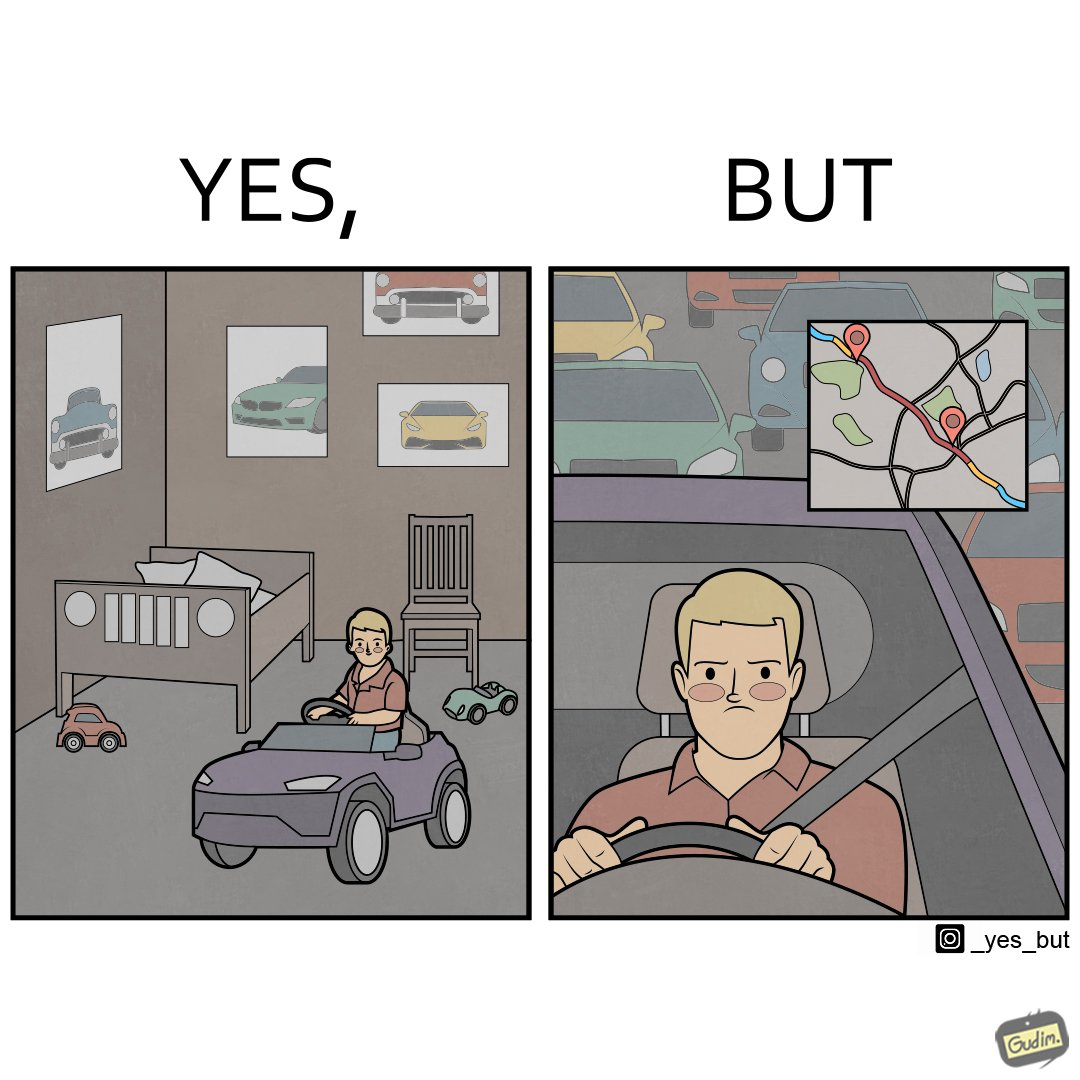What does this image depict? The image is funny beaucse while the person as a child enjoyed being around cars, had various small toy cars and even rode a bigger toy car, as as grown up he does not enjoy being in a car during a traffic jam while he is driving . 